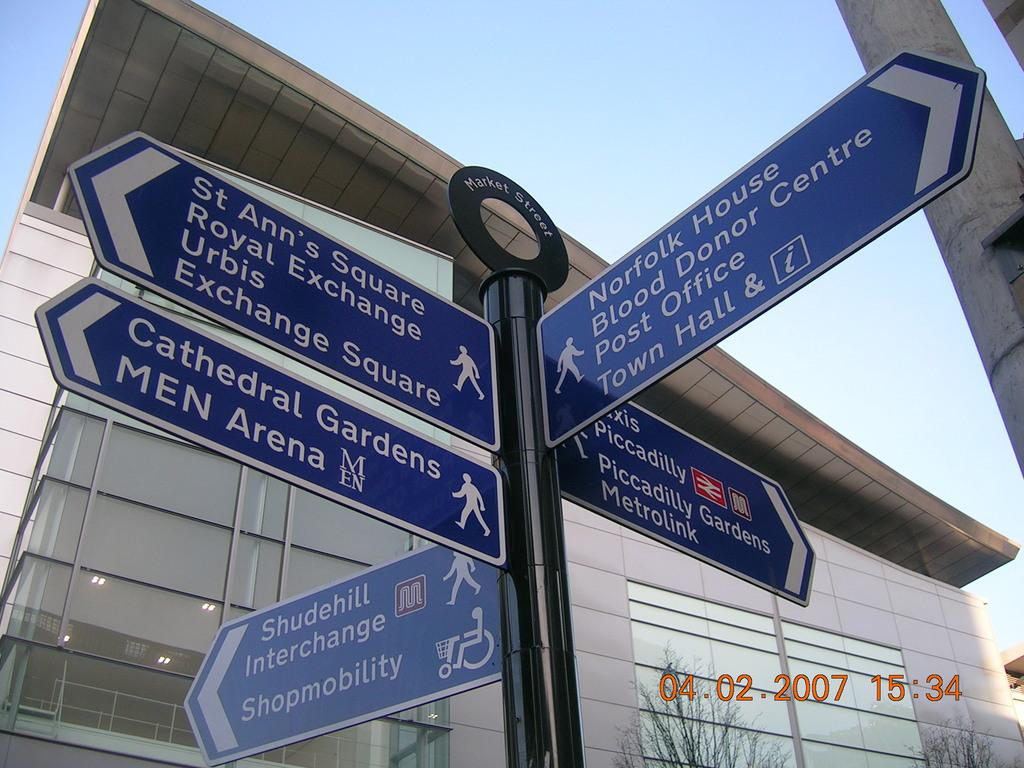What is attached to the pole in the image? There are sign boards attached to the pole in the image. What type of building can be seen in the image? There is a building with glass walls in the image. What type of vegetation is at the bottom of the image? There are trees at the bottom of the image. What can be read or seen in the textually in the image? There is text visible in the image. What is visible at the top of the image? The sky is visible at the top of the image. What type of sponge can be seen absorbing noise in the image? There is no sponge or noise present in the image. What type of harmony is depicted in the image? The image does not depict any harmony; it features a pole with sign boards, a building with glass walls, trees, text, and the sky. 